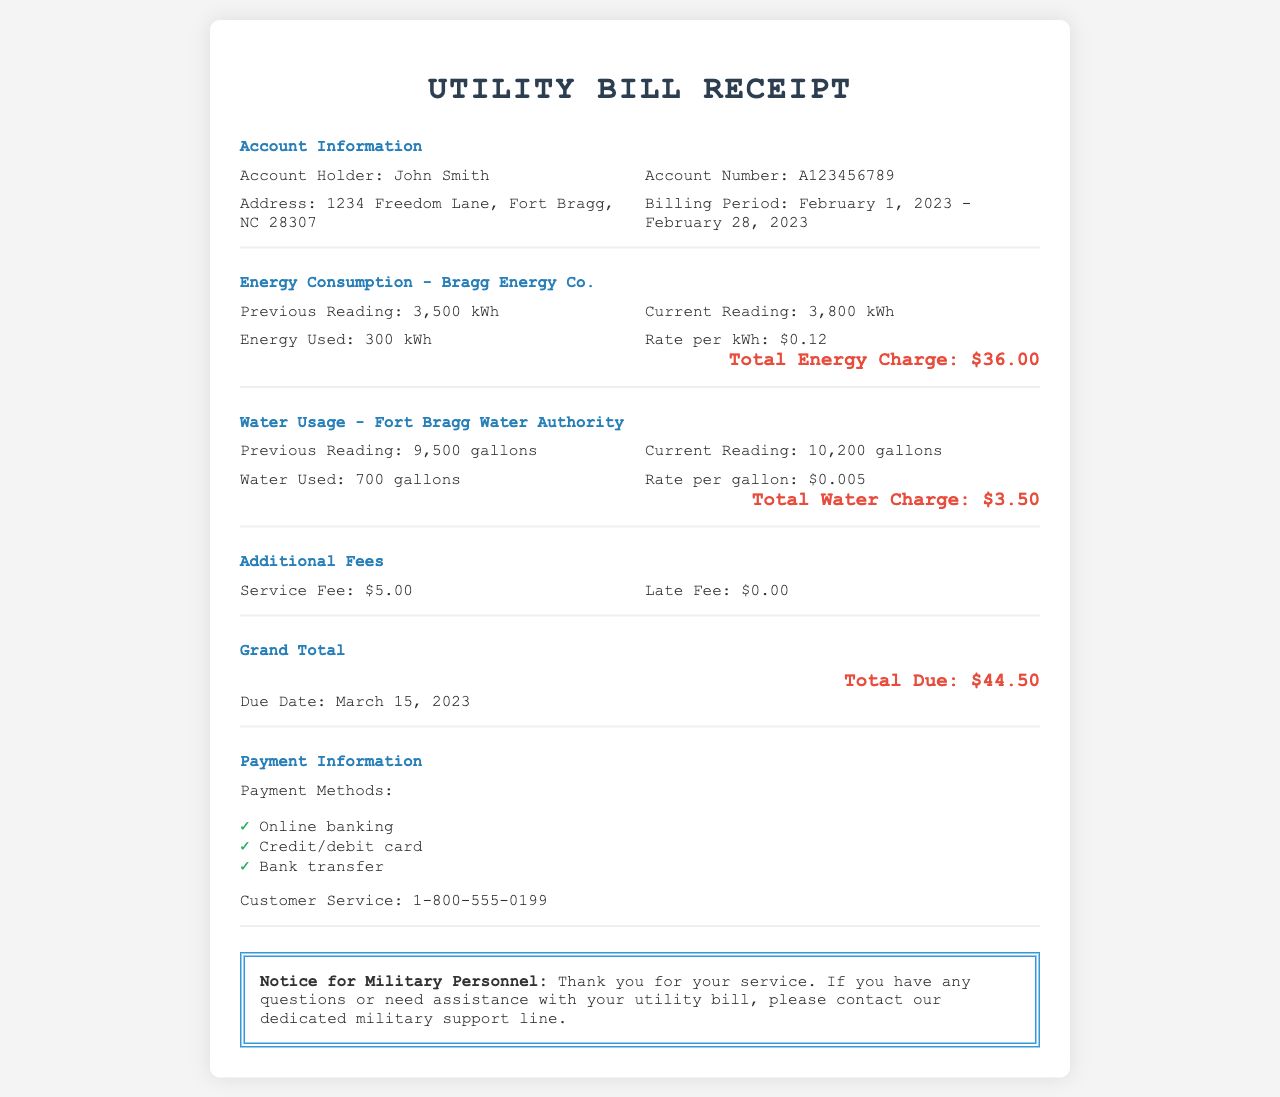what is the account holder's name? The account holder's name is listed in the account information section of the document.
Answer: John Smith what is the billing period for this utility bill? The billing period indicates the range of dates for which the bill is issued.
Answer: February 1, 2023 - February 28, 2023 how much energy was used in February 2023? The energy used is calculated by subtracting the previous reading from the current reading.
Answer: 300 kWh what is the rate per gallon for water usage? The rate per gallon for water usage is stated in the water usage section of the document.
Answer: $0.005 what is the total charge for water usage? The total water charge is provided after calculating the water used by multiplying with the rate per gallon.
Answer: $3.50 how much is the service fee? The service fee is included in the additional fees section of the document.
Answer: $5.00 what is the grand total due for this bill? The grand total is clearly stated at the end of the receipt.
Answer: $44.50 what is the due date for the payment? The due date indicates when the total amount must be paid before any late fees apply.
Answer: March 15, 2023 what methods of payment are accepted? The document lists the methods of payment available for the utility bill.
Answer: Online banking, Credit/debit card, Bank transfer 